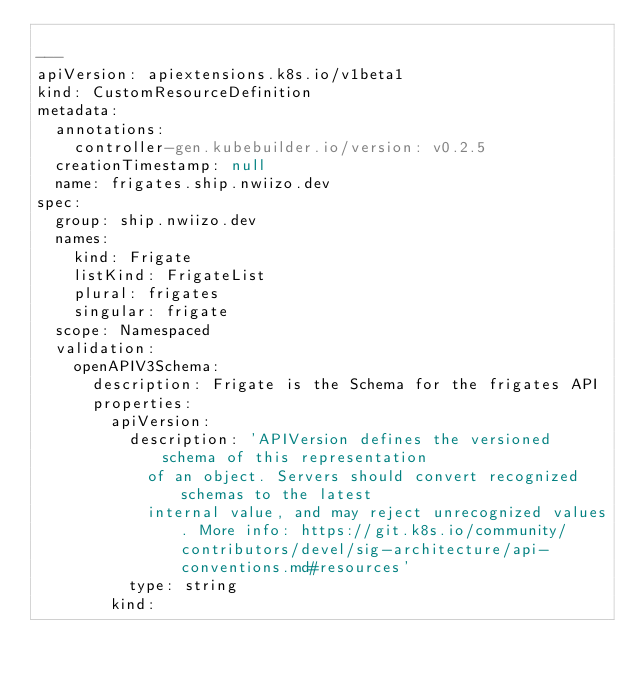<code> <loc_0><loc_0><loc_500><loc_500><_YAML_>
---
apiVersion: apiextensions.k8s.io/v1beta1
kind: CustomResourceDefinition
metadata:
  annotations:
    controller-gen.kubebuilder.io/version: v0.2.5
  creationTimestamp: null
  name: frigates.ship.nwiizo.dev
spec:
  group: ship.nwiizo.dev
  names:
    kind: Frigate
    listKind: FrigateList
    plural: frigates
    singular: frigate
  scope: Namespaced
  validation:
    openAPIV3Schema:
      description: Frigate is the Schema for the frigates API
      properties:
        apiVersion:
          description: 'APIVersion defines the versioned schema of this representation
            of an object. Servers should convert recognized schemas to the latest
            internal value, and may reject unrecognized values. More info: https://git.k8s.io/community/contributors/devel/sig-architecture/api-conventions.md#resources'
          type: string
        kind:</code> 